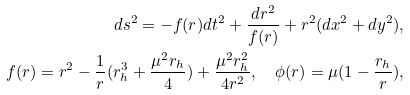Convert formula to latex. <formula><loc_0><loc_0><loc_500><loc_500>d s ^ { 2 } = - f ( r ) d t ^ { 2 } + \frac { d r ^ { 2 } } { f ( r ) } + r ^ { 2 } ( d x ^ { 2 } + d y ^ { 2 } ) , \\ f ( r ) = r ^ { 2 } - \frac { 1 } { r } ( r _ { h } ^ { 3 } + \frac { \mu ^ { 2 } r _ { h } } { 4 } ) + \frac { \mu ^ { 2 } r _ { h } ^ { 2 } } { 4 r ^ { 2 } } , \quad \phi ( r ) = \mu ( 1 - \frac { r _ { h } } { r } ) ,</formula> 